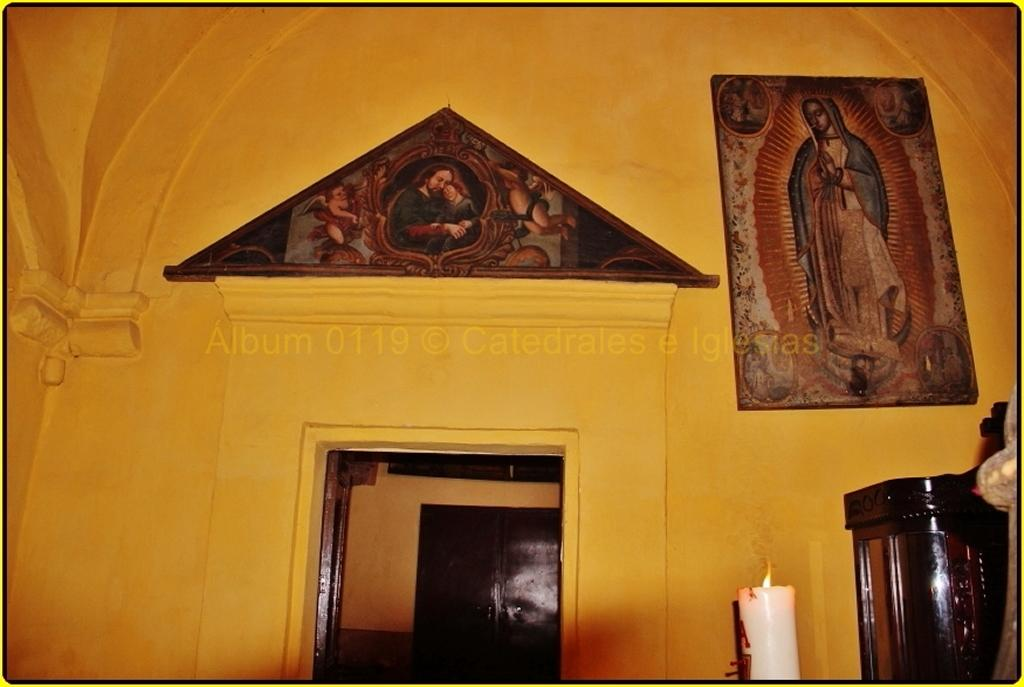What type of space is depicted in the image? The image shows an inner view of a room. What can be seen on the wall in the room? There are photo frames on the wall. What type of furniture is present in the room? There is a cupboard in the room. What is the source of light in the image? A burning candle is visible in the image. What type of writer is sitting at the desk in the image? There is no desk or writer present in the image. What type of lawyer is standing near the cupboard in the image? There is no lawyer present in the image. 